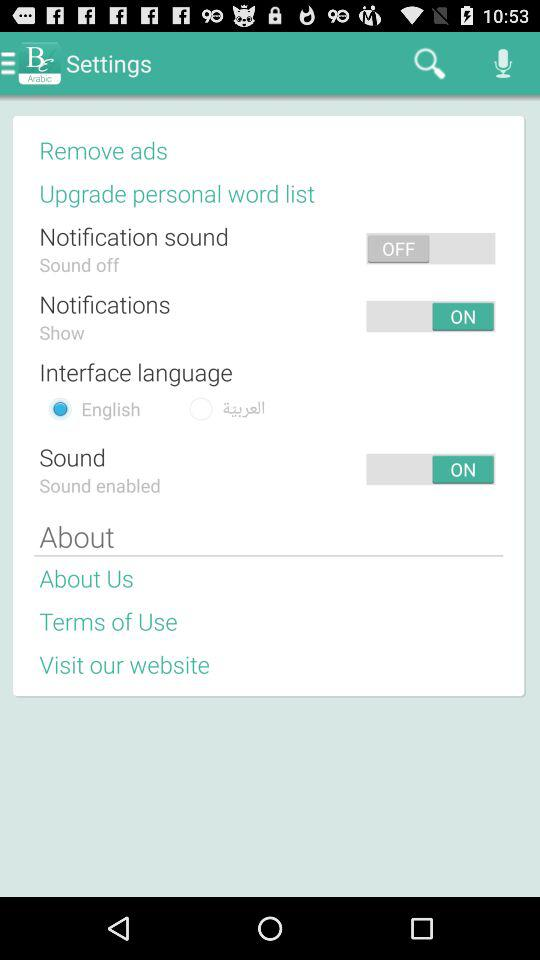What is the status of "Notifications"? The status is "ON". 